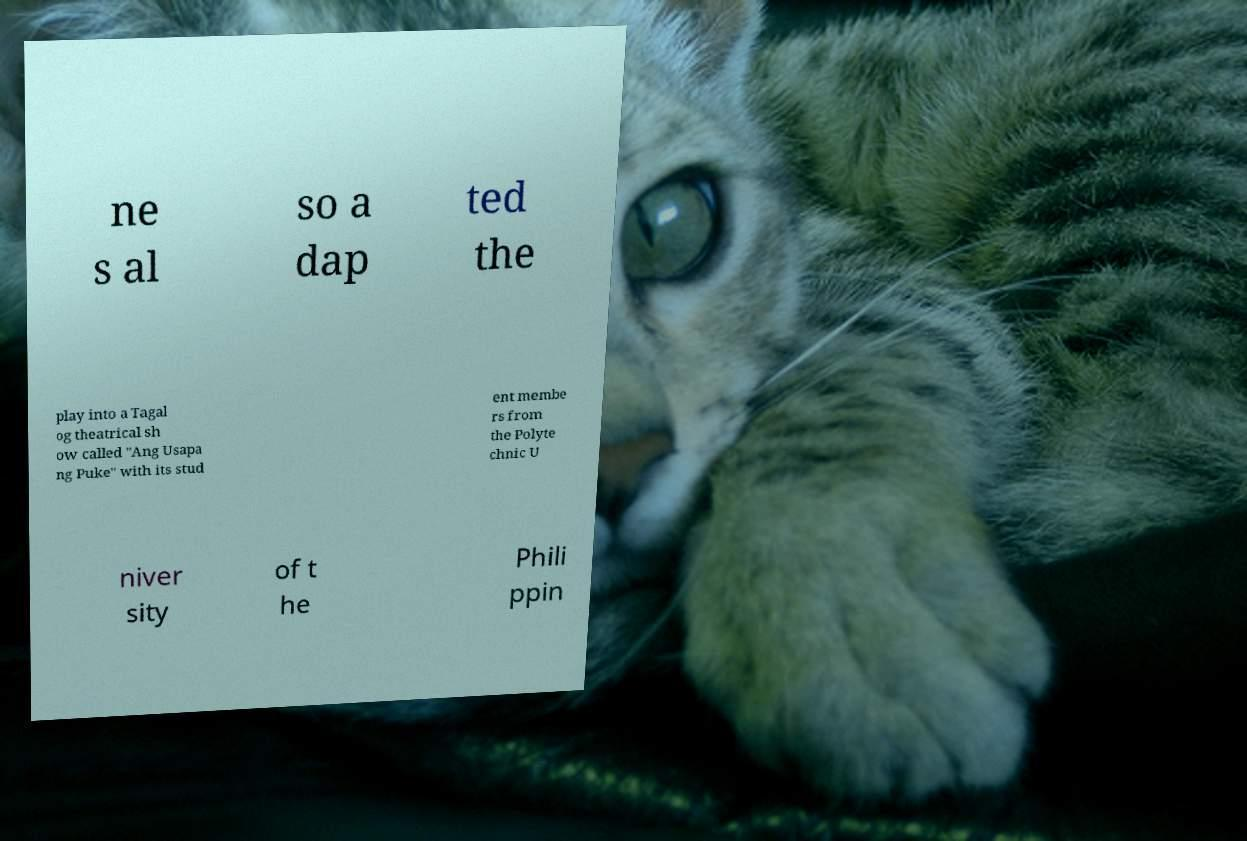Can you accurately transcribe the text from the provided image for me? ne s al so a dap ted the play into a Tagal og theatrical sh ow called "Ang Usapa ng Puke" with its stud ent membe rs from the Polyte chnic U niver sity of t he Phili ppin 